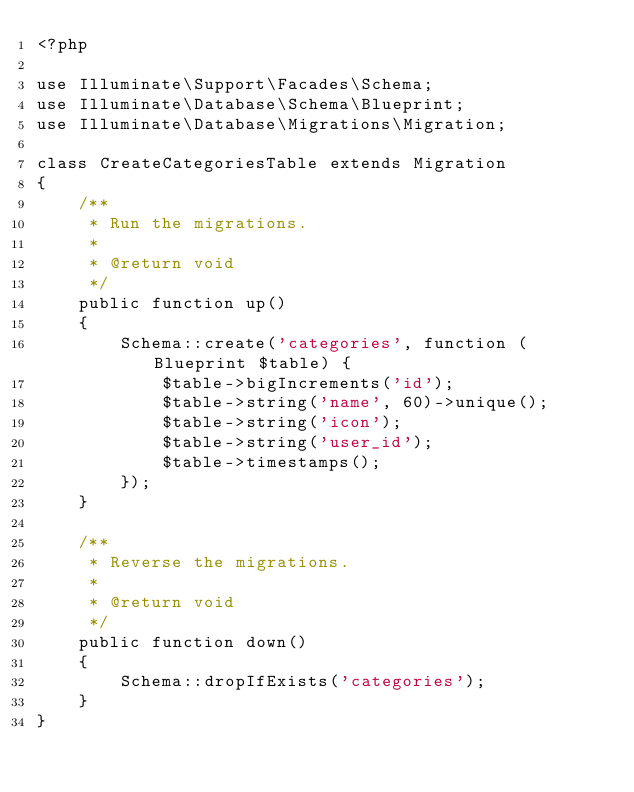Convert code to text. <code><loc_0><loc_0><loc_500><loc_500><_PHP_><?php

use Illuminate\Support\Facades\Schema;
use Illuminate\Database\Schema\Blueprint;
use Illuminate\Database\Migrations\Migration;

class CreateCategoriesTable extends Migration
{
    /**
     * Run the migrations.
     *
     * @return void
     */
    public function up()
    {
        Schema::create('categories', function (Blueprint $table) {
            $table->bigIncrements('id');
            $table->string('name', 60)->unique();
            $table->string('icon');
            $table->string('user_id');
            $table->timestamps();
        });
    }

    /**
     * Reverse the migrations.
     *
     * @return void
     */
    public function down()
    {
        Schema::dropIfExists('categories');
    }
}
</code> 